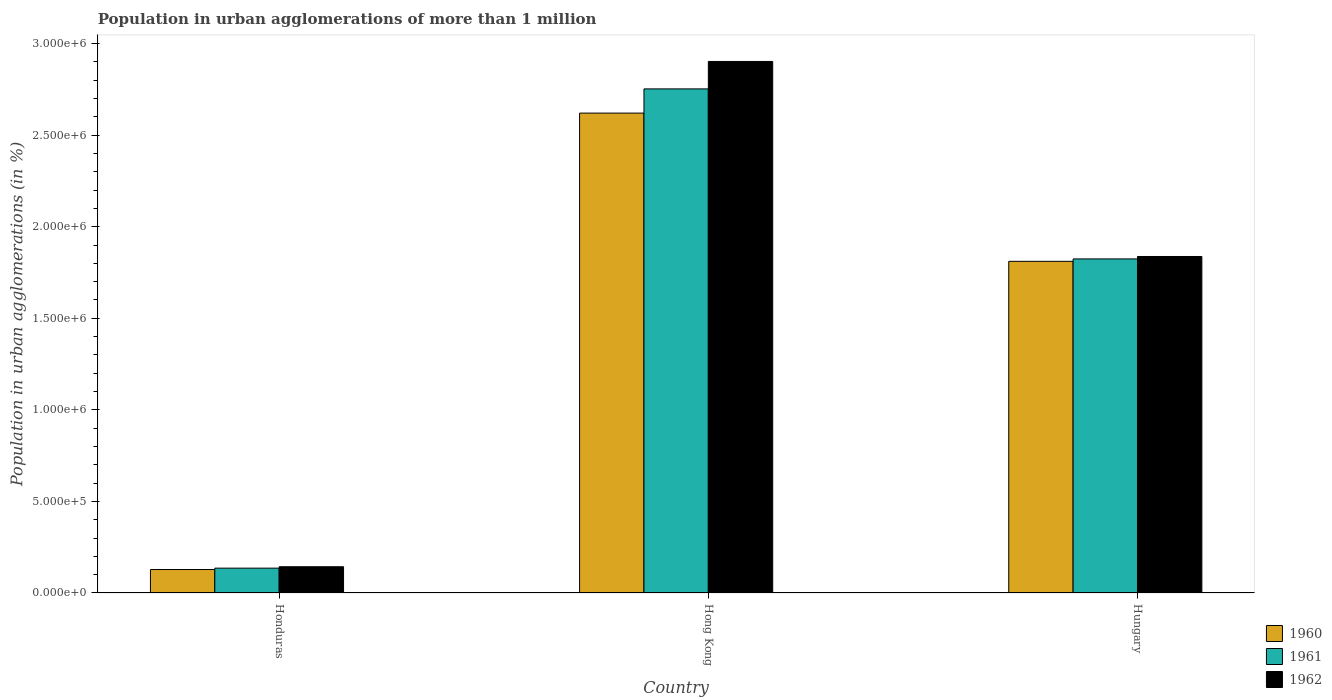How many different coloured bars are there?
Offer a terse response. 3. Are the number of bars per tick equal to the number of legend labels?
Make the answer very short. Yes. How many bars are there on the 2nd tick from the left?
Offer a terse response. 3. What is the label of the 2nd group of bars from the left?
Provide a short and direct response. Hong Kong. In how many cases, is the number of bars for a given country not equal to the number of legend labels?
Provide a succinct answer. 0. What is the population in urban agglomerations in 1960 in Hungary?
Your response must be concise. 1.81e+06. Across all countries, what is the maximum population in urban agglomerations in 1961?
Give a very brief answer. 2.75e+06. Across all countries, what is the minimum population in urban agglomerations in 1960?
Offer a very short reply. 1.28e+05. In which country was the population in urban agglomerations in 1960 maximum?
Offer a very short reply. Hong Kong. In which country was the population in urban agglomerations in 1962 minimum?
Your answer should be very brief. Honduras. What is the total population in urban agglomerations in 1960 in the graph?
Provide a succinct answer. 4.56e+06. What is the difference between the population in urban agglomerations in 1961 in Hong Kong and that in Hungary?
Provide a succinct answer. 9.28e+05. What is the difference between the population in urban agglomerations in 1962 in Honduras and the population in urban agglomerations in 1960 in Hong Kong?
Offer a terse response. -2.48e+06. What is the average population in urban agglomerations in 1960 per country?
Your answer should be very brief. 1.52e+06. What is the difference between the population in urban agglomerations of/in 1961 and population in urban agglomerations of/in 1962 in Honduras?
Ensure brevity in your answer.  -7731. What is the ratio of the population in urban agglomerations in 1960 in Hong Kong to that in Hungary?
Ensure brevity in your answer.  1.45. Is the population in urban agglomerations in 1960 in Honduras less than that in Hong Kong?
Your answer should be very brief. Yes. Is the difference between the population in urban agglomerations in 1961 in Honduras and Hungary greater than the difference between the population in urban agglomerations in 1962 in Honduras and Hungary?
Give a very brief answer. Yes. What is the difference between the highest and the second highest population in urban agglomerations in 1960?
Offer a very short reply. -8.09e+05. What is the difference between the highest and the lowest population in urban agglomerations in 1962?
Ensure brevity in your answer.  2.76e+06. In how many countries, is the population in urban agglomerations in 1961 greater than the average population in urban agglomerations in 1961 taken over all countries?
Make the answer very short. 2. What does the 1st bar from the left in Honduras represents?
Make the answer very short. 1960. What does the 1st bar from the right in Hungary represents?
Your answer should be compact. 1962. How many countries are there in the graph?
Your answer should be compact. 3. What is the difference between two consecutive major ticks on the Y-axis?
Provide a short and direct response. 5.00e+05. Does the graph contain any zero values?
Offer a very short reply. No. Where does the legend appear in the graph?
Your answer should be compact. Bottom right. How many legend labels are there?
Offer a very short reply. 3. How are the legend labels stacked?
Ensure brevity in your answer.  Vertical. What is the title of the graph?
Ensure brevity in your answer.  Population in urban agglomerations of more than 1 million. Does "1971" appear as one of the legend labels in the graph?
Make the answer very short. No. What is the label or title of the X-axis?
Provide a succinct answer. Country. What is the label or title of the Y-axis?
Offer a very short reply. Population in urban agglomerations (in %). What is the Population in urban agglomerations (in %) in 1960 in Honduras?
Your answer should be compact. 1.28e+05. What is the Population in urban agglomerations (in %) in 1961 in Honduras?
Offer a terse response. 1.36e+05. What is the Population in urban agglomerations (in %) of 1962 in Honduras?
Ensure brevity in your answer.  1.43e+05. What is the Population in urban agglomerations (in %) of 1960 in Hong Kong?
Your answer should be very brief. 2.62e+06. What is the Population in urban agglomerations (in %) of 1961 in Hong Kong?
Offer a very short reply. 2.75e+06. What is the Population in urban agglomerations (in %) in 1962 in Hong Kong?
Provide a succinct answer. 2.90e+06. What is the Population in urban agglomerations (in %) of 1960 in Hungary?
Provide a succinct answer. 1.81e+06. What is the Population in urban agglomerations (in %) of 1961 in Hungary?
Offer a terse response. 1.82e+06. What is the Population in urban agglomerations (in %) of 1962 in Hungary?
Keep it short and to the point. 1.84e+06. Across all countries, what is the maximum Population in urban agglomerations (in %) of 1960?
Make the answer very short. 2.62e+06. Across all countries, what is the maximum Population in urban agglomerations (in %) of 1961?
Keep it short and to the point. 2.75e+06. Across all countries, what is the maximum Population in urban agglomerations (in %) in 1962?
Offer a terse response. 2.90e+06. Across all countries, what is the minimum Population in urban agglomerations (in %) in 1960?
Offer a very short reply. 1.28e+05. Across all countries, what is the minimum Population in urban agglomerations (in %) of 1961?
Give a very brief answer. 1.36e+05. Across all countries, what is the minimum Population in urban agglomerations (in %) of 1962?
Your response must be concise. 1.43e+05. What is the total Population in urban agglomerations (in %) of 1960 in the graph?
Make the answer very short. 4.56e+06. What is the total Population in urban agglomerations (in %) in 1961 in the graph?
Offer a very short reply. 4.71e+06. What is the total Population in urban agglomerations (in %) in 1962 in the graph?
Ensure brevity in your answer.  4.88e+06. What is the difference between the Population in urban agglomerations (in %) in 1960 in Honduras and that in Hong Kong?
Ensure brevity in your answer.  -2.49e+06. What is the difference between the Population in urban agglomerations (in %) of 1961 in Honduras and that in Hong Kong?
Provide a short and direct response. -2.62e+06. What is the difference between the Population in urban agglomerations (in %) of 1962 in Honduras and that in Hong Kong?
Provide a short and direct response. -2.76e+06. What is the difference between the Population in urban agglomerations (in %) of 1960 in Honduras and that in Hungary?
Make the answer very short. -1.68e+06. What is the difference between the Population in urban agglomerations (in %) of 1961 in Honduras and that in Hungary?
Offer a terse response. -1.69e+06. What is the difference between the Population in urban agglomerations (in %) in 1962 in Honduras and that in Hungary?
Your answer should be compact. -1.69e+06. What is the difference between the Population in urban agglomerations (in %) in 1960 in Hong Kong and that in Hungary?
Offer a very short reply. 8.09e+05. What is the difference between the Population in urban agglomerations (in %) of 1961 in Hong Kong and that in Hungary?
Your answer should be compact. 9.28e+05. What is the difference between the Population in urban agglomerations (in %) of 1962 in Hong Kong and that in Hungary?
Offer a terse response. 1.07e+06. What is the difference between the Population in urban agglomerations (in %) of 1960 in Honduras and the Population in urban agglomerations (in %) of 1961 in Hong Kong?
Provide a short and direct response. -2.62e+06. What is the difference between the Population in urban agglomerations (in %) of 1960 in Honduras and the Population in urban agglomerations (in %) of 1962 in Hong Kong?
Offer a terse response. -2.77e+06. What is the difference between the Population in urban agglomerations (in %) in 1961 in Honduras and the Population in urban agglomerations (in %) in 1962 in Hong Kong?
Your answer should be compact. -2.77e+06. What is the difference between the Population in urban agglomerations (in %) of 1960 in Honduras and the Population in urban agglomerations (in %) of 1961 in Hungary?
Your answer should be very brief. -1.70e+06. What is the difference between the Population in urban agglomerations (in %) of 1960 in Honduras and the Population in urban agglomerations (in %) of 1962 in Hungary?
Your response must be concise. -1.71e+06. What is the difference between the Population in urban agglomerations (in %) in 1961 in Honduras and the Population in urban agglomerations (in %) in 1962 in Hungary?
Keep it short and to the point. -1.70e+06. What is the difference between the Population in urban agglomerations (in %) in 1960 in Hong Kong and the Population in urban agglomerations (in %) in 1961 in Hungary?
Provide a succinct answer. 7.96e+05. What is the difference between the Population in urban agglomerations (in %) in 1960 in Hong Kong and the Population in urban agglomerations (in %) in 1962 in Hungary?
Give a very brief answer. 7.83e+05. What is the difference between the Population in urban agglomerations (in %) of 1961 in Hong Kong and the Population in urban agglomerations (in %) of 1962 in Hungary?
Provide a succinct answer. 9.15e+05. What is the average Population in urban agglomerations (in %) in 1960 per country?
Make the answer very short. 1.52e+06. What is the average Population in urban agglomerations (in %) in 1961 per country?
Provide a succinct answer. 1.57e+06. What is the average Population in urban agglomerations (in %) of 1962 per country?
Your answer should be very brief. 1.63e+06. What is the difference between the Population in urban agglomerations (in %) of 1960 and Population in urban agglomerations (in %) of 1961 in Honduras?
Your answer should be compact. -7454. What is the difference between the Population in urban agglomerations (in %) of 1960 and Population in urban agglomerations (in %) of 1962 in Honduras?
Provide a short and direct response. -1.52e+04. What is the difference between the Population in urban agglomerations (in %) in 1961 and Population in urban agglomerations (in %) in 1962 in Honduras?
Provide a succinct answer. -7731. What is the difference between the Population in urban agglomerations (in %) in 1960 and Population in urban agglomerations (in %) in 1961 in Hong Kong?
Ensure brevity in your answer.  -1.32e+05. What is the difference between the Population in urban agglomerations (in %) of 1960 and Population in urban agglomerations (in %) of 1962 in Hong Kong?
Give a very brief answer. -2.82e+05. What is the difference between the Population in urban agglomerations (in %) of 1961 and Population in urban agglomerations (in %) of 1962 in Hong Kong?
Your response must be concise. -1.50e+05. What is the difference between the Population in urban agglomerations (in %) in 1960 and Population in urban agglomerations (in %) in 1961 in Hungary?
Your response must be concise. -1.32e+04. What is the difference between the Population in urban agglomerations (in %) of 1960 and Population in urban agglomerations (in %) of 1962 in Hungary?
Your answer should be very brief. -2.64e+04. What is the difference between the Population in urban agglomerations (in %) in 1961 and Population in urban agglomerations (in %) in 1962 in Hungary?
Make the answer very short. -1.33e+04. What is the ratio of the Population in urban agglomerations (in %) of 1960 in Honduras to that in Hong Kong?
Your answer should be compact. 0.05. What is the ratio of the Population in urban agglomerations (in %) of 1961 in Honduras to that in Hong Kong?
Keep it short and to the point. 0.05. What is the ratio of the Population in urban agglomerations (in %) of 1962 in Honduras to that in Hong Kong?
Provide a short and direct response. 0.05. What is the ratio of the Population in urban agglomerations (in %) of 1960 in Honduras to that in Hungary?
Your answer should be compact. 0.07. What is the ratio of the Population in urban agglomerations (in %) in 1961 in Honduras to that in Hungary?
Keep it short and to the point. 0.07. What is the ratio of the Population in urban agglomerations (in %) in 1962 in Honduras to that in Hungary?
Offer a very short reply. 0.08. What is the ratio of the Population in urban agglomerations (in %) in 1960 in Hong Kong to that in Hungary?
Provide a short and direct response. 1.45. What is the ratio of the Population in urban agglomerations (in %) of 1961 in Hong Kong to that in Hungary?
Provide a succinct answer. 1.51. What is the ratio of the Population in urban agglomerations (in %) in 1962 in Hong Kong to that in Hungary?
Make the answer very short. 1.58. What is the difference between the highest and the second highest Population in urban agglomerations (in %) of 1960?
Give a very brief answer. 8.09e+05. What is the difference between the highest and the second highest Population in urban agglomerations (in %) of 1961?
Provide a succinct answer. 9.28e+05. What is the difference between the highest and the second highest Population in urban agglomerations (in %) in 1962?
Make the answer very short. 1.07e+06. What is the difference between the highest and the lowest Population in urban agglomerations (in %) in 1960?
Provide a short and direct response. 2.49e+06. What is the difference between the highest and the lowest Population in urban agglomerations (in %) in 1961?
Offer a terse response. 2.62e+06. What is the difference between the highest and the lowest Population in urban agglomerations (in %) in 1962?
Ensure brevity in your answer.  2.76e+06. 